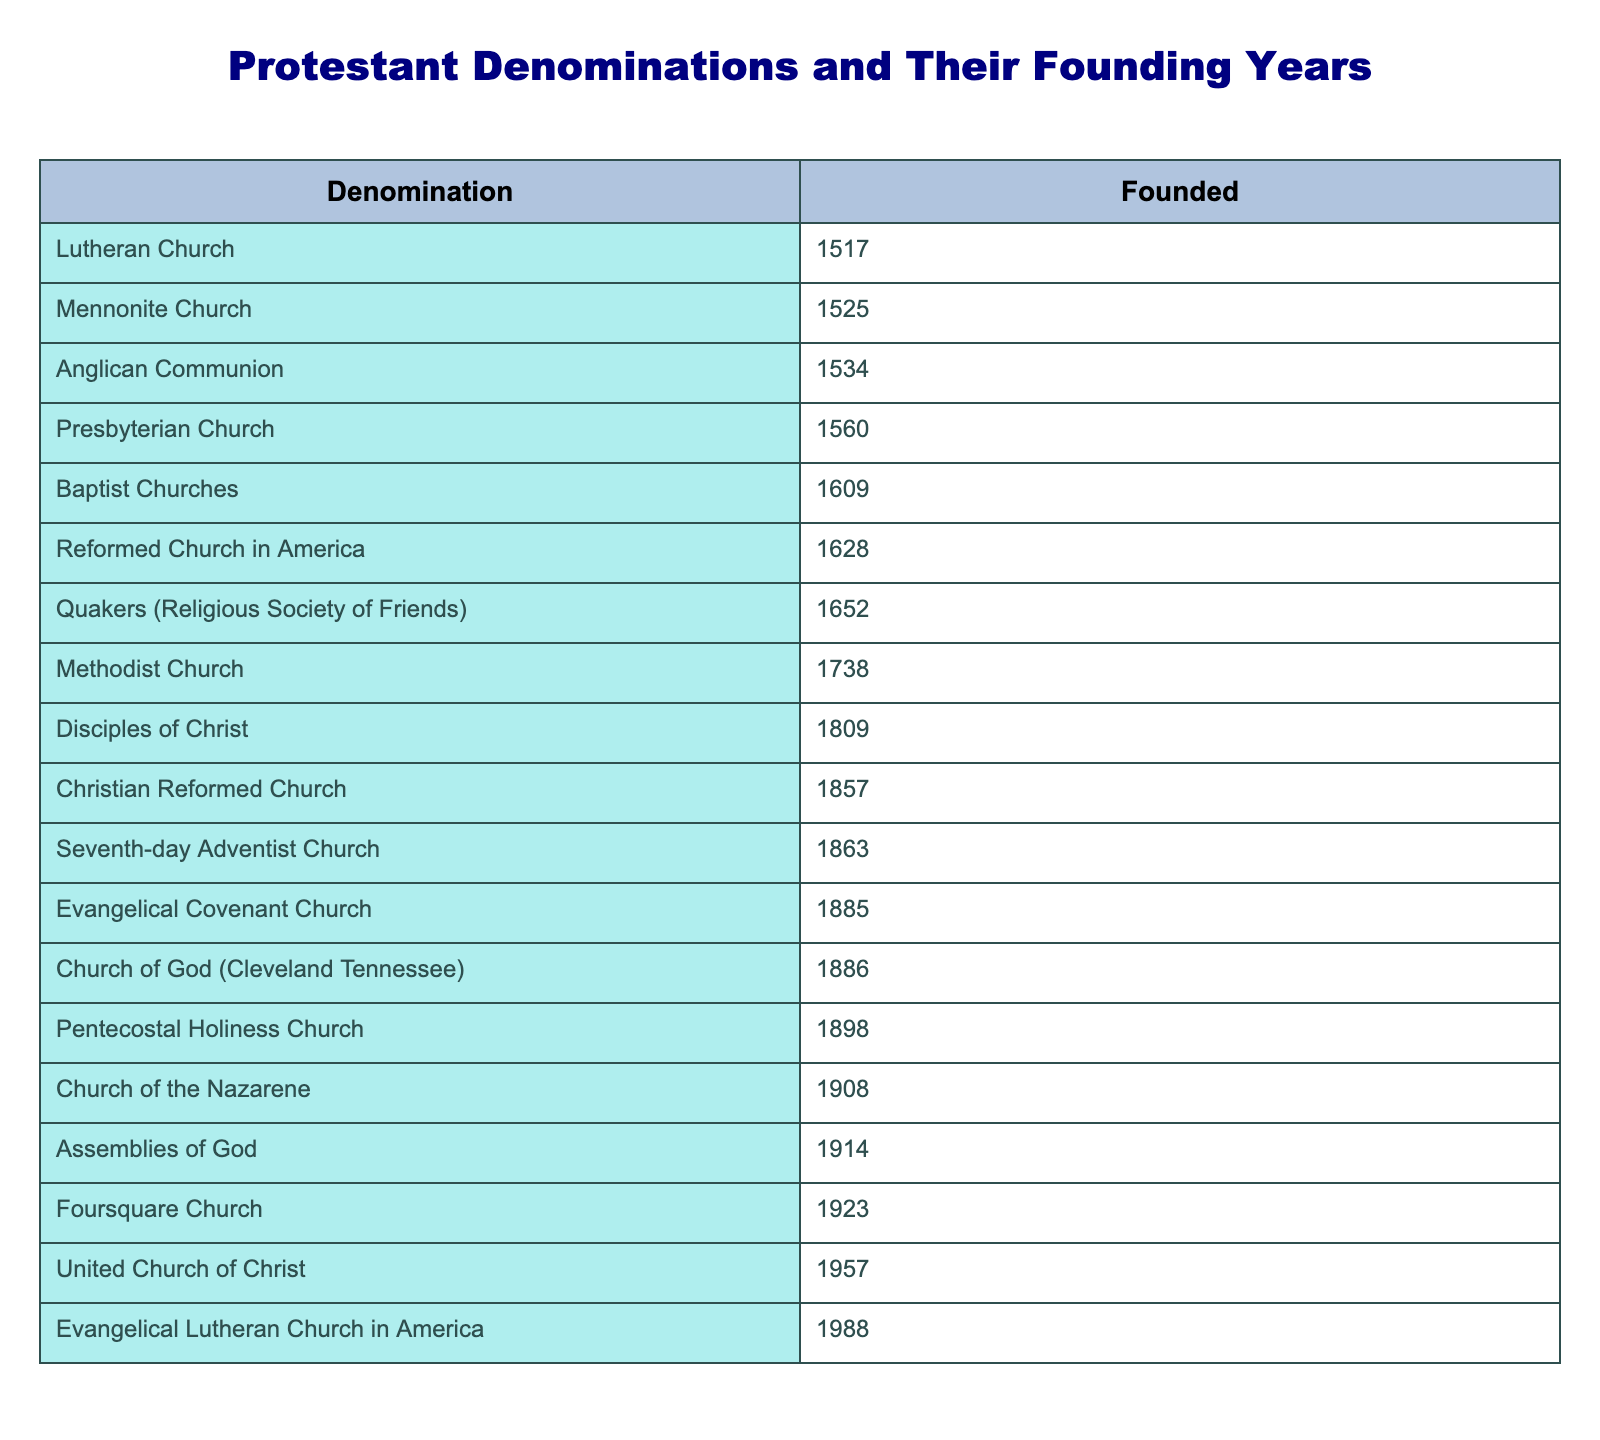What year was the Anglican Communion founded? The table lists the Anglican Communion and its founding year as 1534.
Answer: 1534 Which denomination was founded in the 17th century? Checking the table, we can see that the Quakers (Religious Society of Friends) was founded in 1652, which is in the 17th century.
Answer: Quakers (Religious Society of Friends) How many denominations were founded before the 18th century? Examining the table, the denominations founded before 1700 are Lutheran Church (1517), Anglican Communion (1534), Presbyterian Church (1560), Baptist Churches (1609), Mennonite Church (1525), and Quakers (1652). This totals to 6.
Answer: 6 Which denomination has the most recent founding year? Looking at the 'Founded' column in the table, the most recent year listed is 1988 for the Evangelical Lutheran Church in America.
Answer: Evangelical Lutheran Church in America What is the difference in founding years between the Baptist Churches and the Methodist Church? The Baptist Churches were founded in 1609, and the Methodist Church in 1738. Subtracting gives 1738 - 1609 = 129 years difference.
Answer: 129 Is the Seventh-day Adventist Church older than the Assemblies of God? The Seventh-day Adventist Church was founded in 1863 and the Assemblies of God in 1914. 1863 is less than 1914, which confirms that the Seventh-day Adventist Church is indeed older.
Answer: Yes Which denomination was founded in the same year as the Church of the Nazarene? The Church of the Nazarene was founded in 1908, and so we will check for any others in that year. The table shows that there is no other denomination listed for that year.
Answer: None What is the average founding year of the first five denominations listed in the table? The first five denominations are Lutheran Church (1517), Anglican Communion (1534), Presbyterian Church (1560), Baptist Churches (1609), and Mennonite Church (1525). Their founding years sum to 1517 + 1534 + 1560 + 1609 + 1525 = 7755. Dividing by 5 gives an average founding year of 1551.
Answer: 1551 Which denominations were founded between 1800 and 1900? The denominations listed within that range based on the founding years are Disciples of Christ (1809), Christian Reformed Church (1857), Evangelical Covenant Church (1885), Church of God (Cleveland Tennessee) (1886), Pentecostal Holiness Church (1898), and the Seventh-day Adventist Church (1863). Counting these gives us 6 denominations.
Answer: 6 Are there more denominations founded in the 20th century than in the 19th century? From the table, those founded in the 20th century are Assemblies of God (1914), Church of the Nazarene (1908), Foursquare Church (1923), and Evangelical Lutheran Church in America (1988) - totaling 4. In the 19th century are Seventh-day Adventist Church (1863), Pentecostal Holiness Church (1898), Christian Reformed Church (1857), Church of God (Cleveland Tennessee) (1886), and Evangelical Covenant Church (1885) which totals 5. Thus, 5 in the 19th century is greater than 4 in the 20th century.
Answer: No 